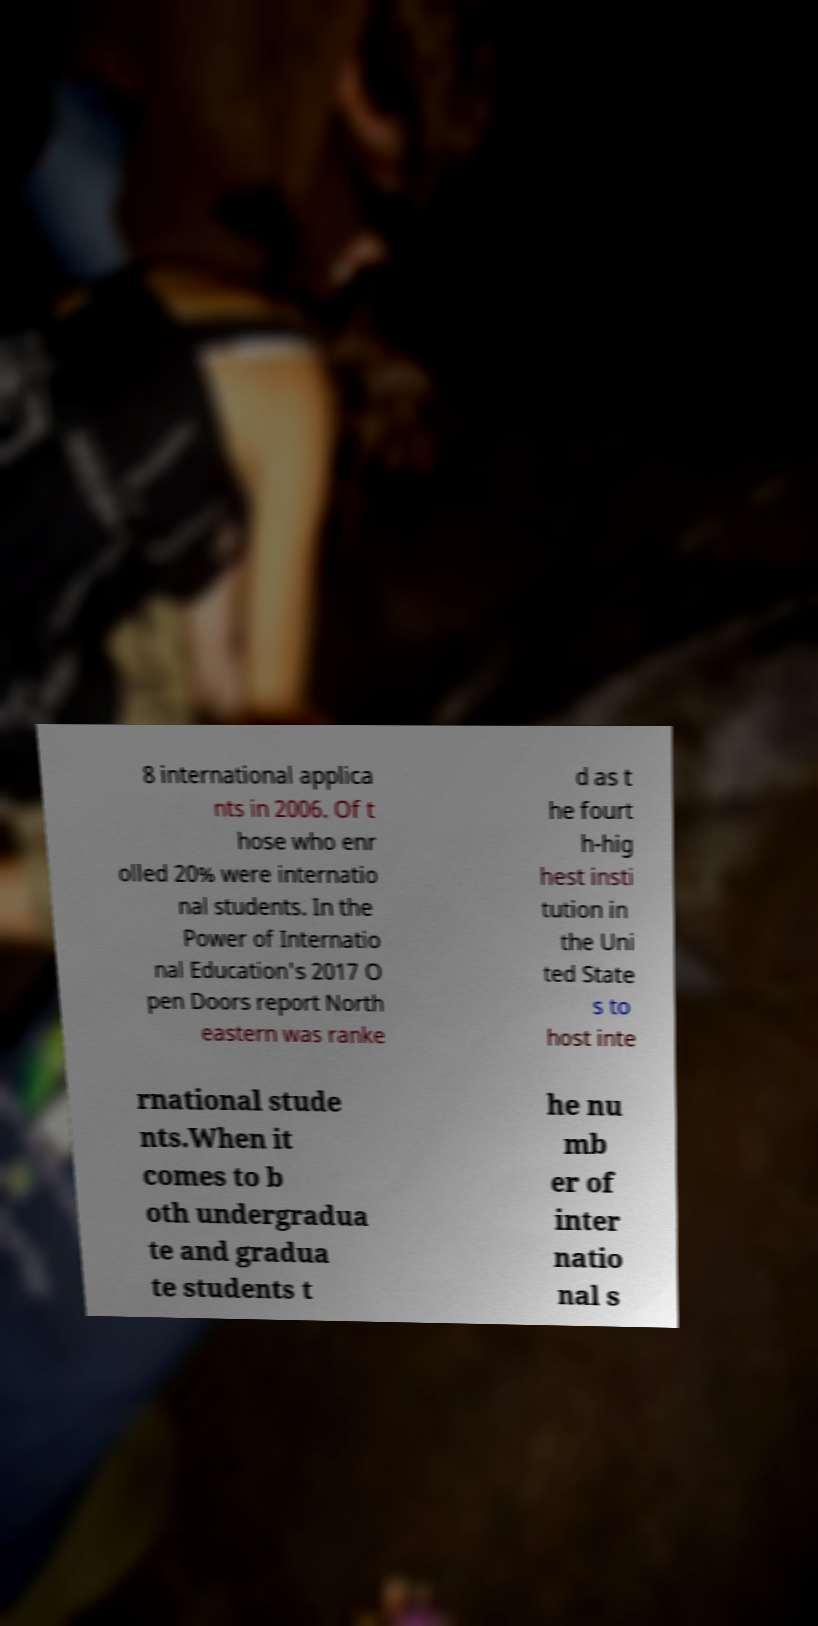Please identify and transcribe the text found in this image. 8 international applica nts in 2006. Of t hose who enr olled 20% were internatio nal students. In the Power of Internatio nal Education's 2017 O pen Doors report North eastern was ranke d as t he fourt h-hig hest insti tution in the Uni ted State s to host inte rnational stude nts.When it comes to b oth undergradua te and gradua te students t he nu mb er of inter natio nal s 